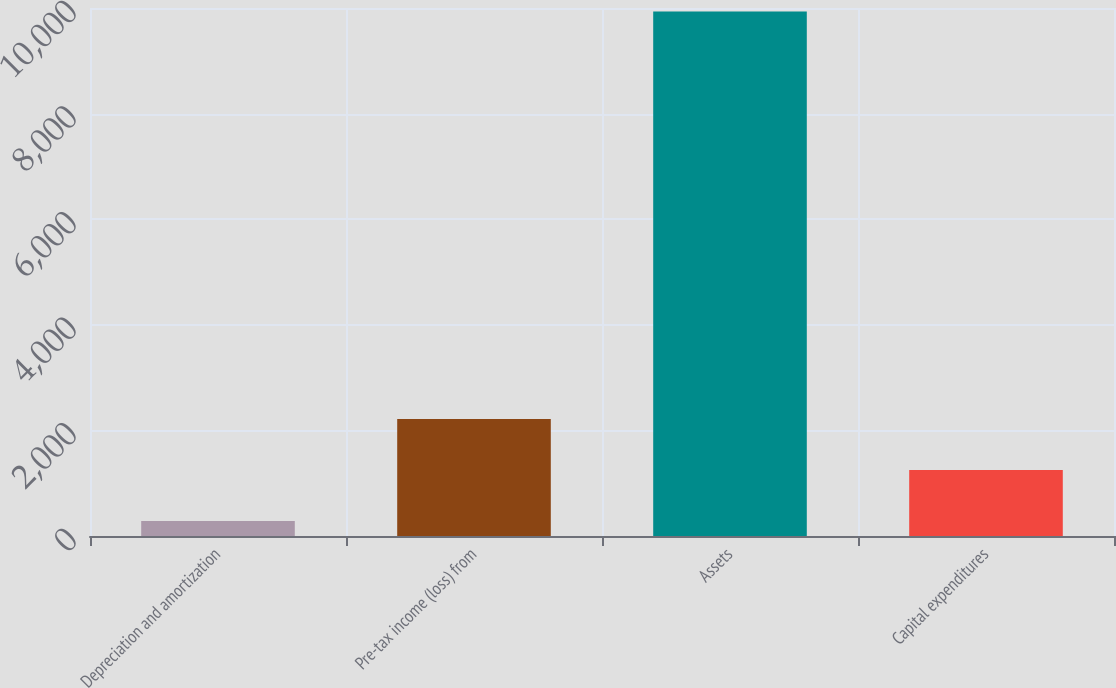Convert chart. <chart><loc_0><loc_0><loc_500><loc_500><bar_chart><fcel>Depreciation and amortization<fcel>Pre-tax income (loss) from<fcel>Assets<fcel>Capital expenditures<nl><fcel>285<fcel>2215.2<fcel>9936<fcel>1250.1<nl></chart> 